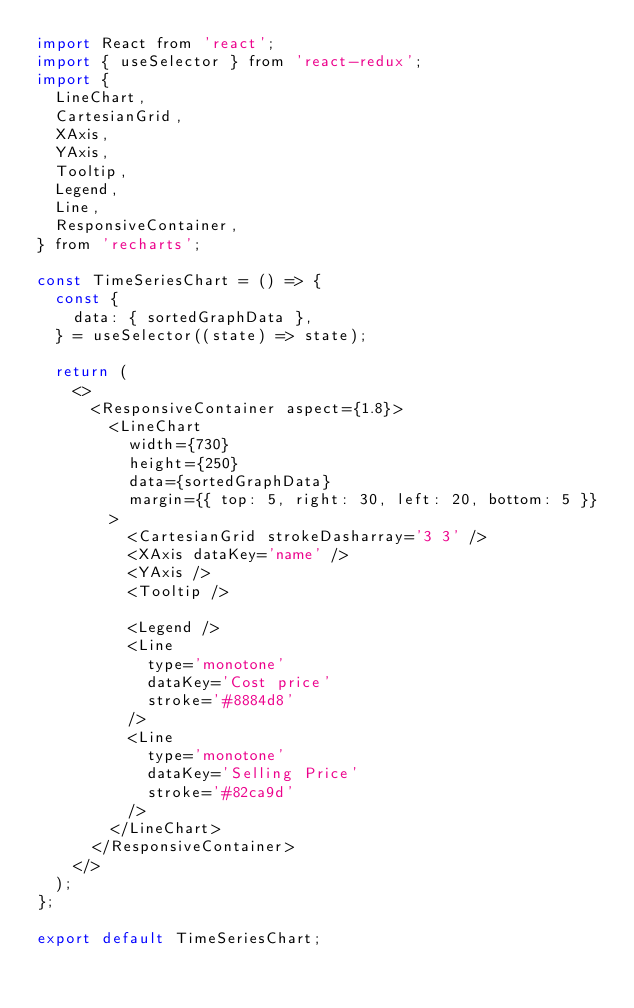Convert code to text. <code><loc_0><loc_0><loc_500><loc_500><_JavaScript_>import React from 'react';
import { useSelector } from 'react-redux';
import {
	LineChart,
	CartesianGrid,
	XAxis,
	YAxis,
	Tooltip,
	Legend,
	Line,
	ResponsiveContainer,
} from 'recharts';

const TimeSeriesChart = () => {
	const {
		data: { sortedGraphData },
	} = useSelector((state) => state);

	return (
		<>
			<ResponsiveContainer aspect={1.8}>
				<LineChart
					width={730}
					height={250}
					data={sortedGraphData}
					margin={{ top: 5, right: 30, left: 20, bottom: 5 }}
				>
					<CartesianGrid strokeDasharray='3 3' />
					<XAxis dataKey='name' />
					<YAxis />
					<Tooltip />

					<Legend />
					<Line
						type='monotone'
						dataKey='Cost price'
						stroke='#8884d8'
					/>
					<Line
						type='monotone'
						dataKey='Selling Price'
						stroke='#82ca9d'
					/>
				</LineChart>
			</ResponsiveContainer>
		</>
	);
};

export default TimeSeriesChart;
</code> 